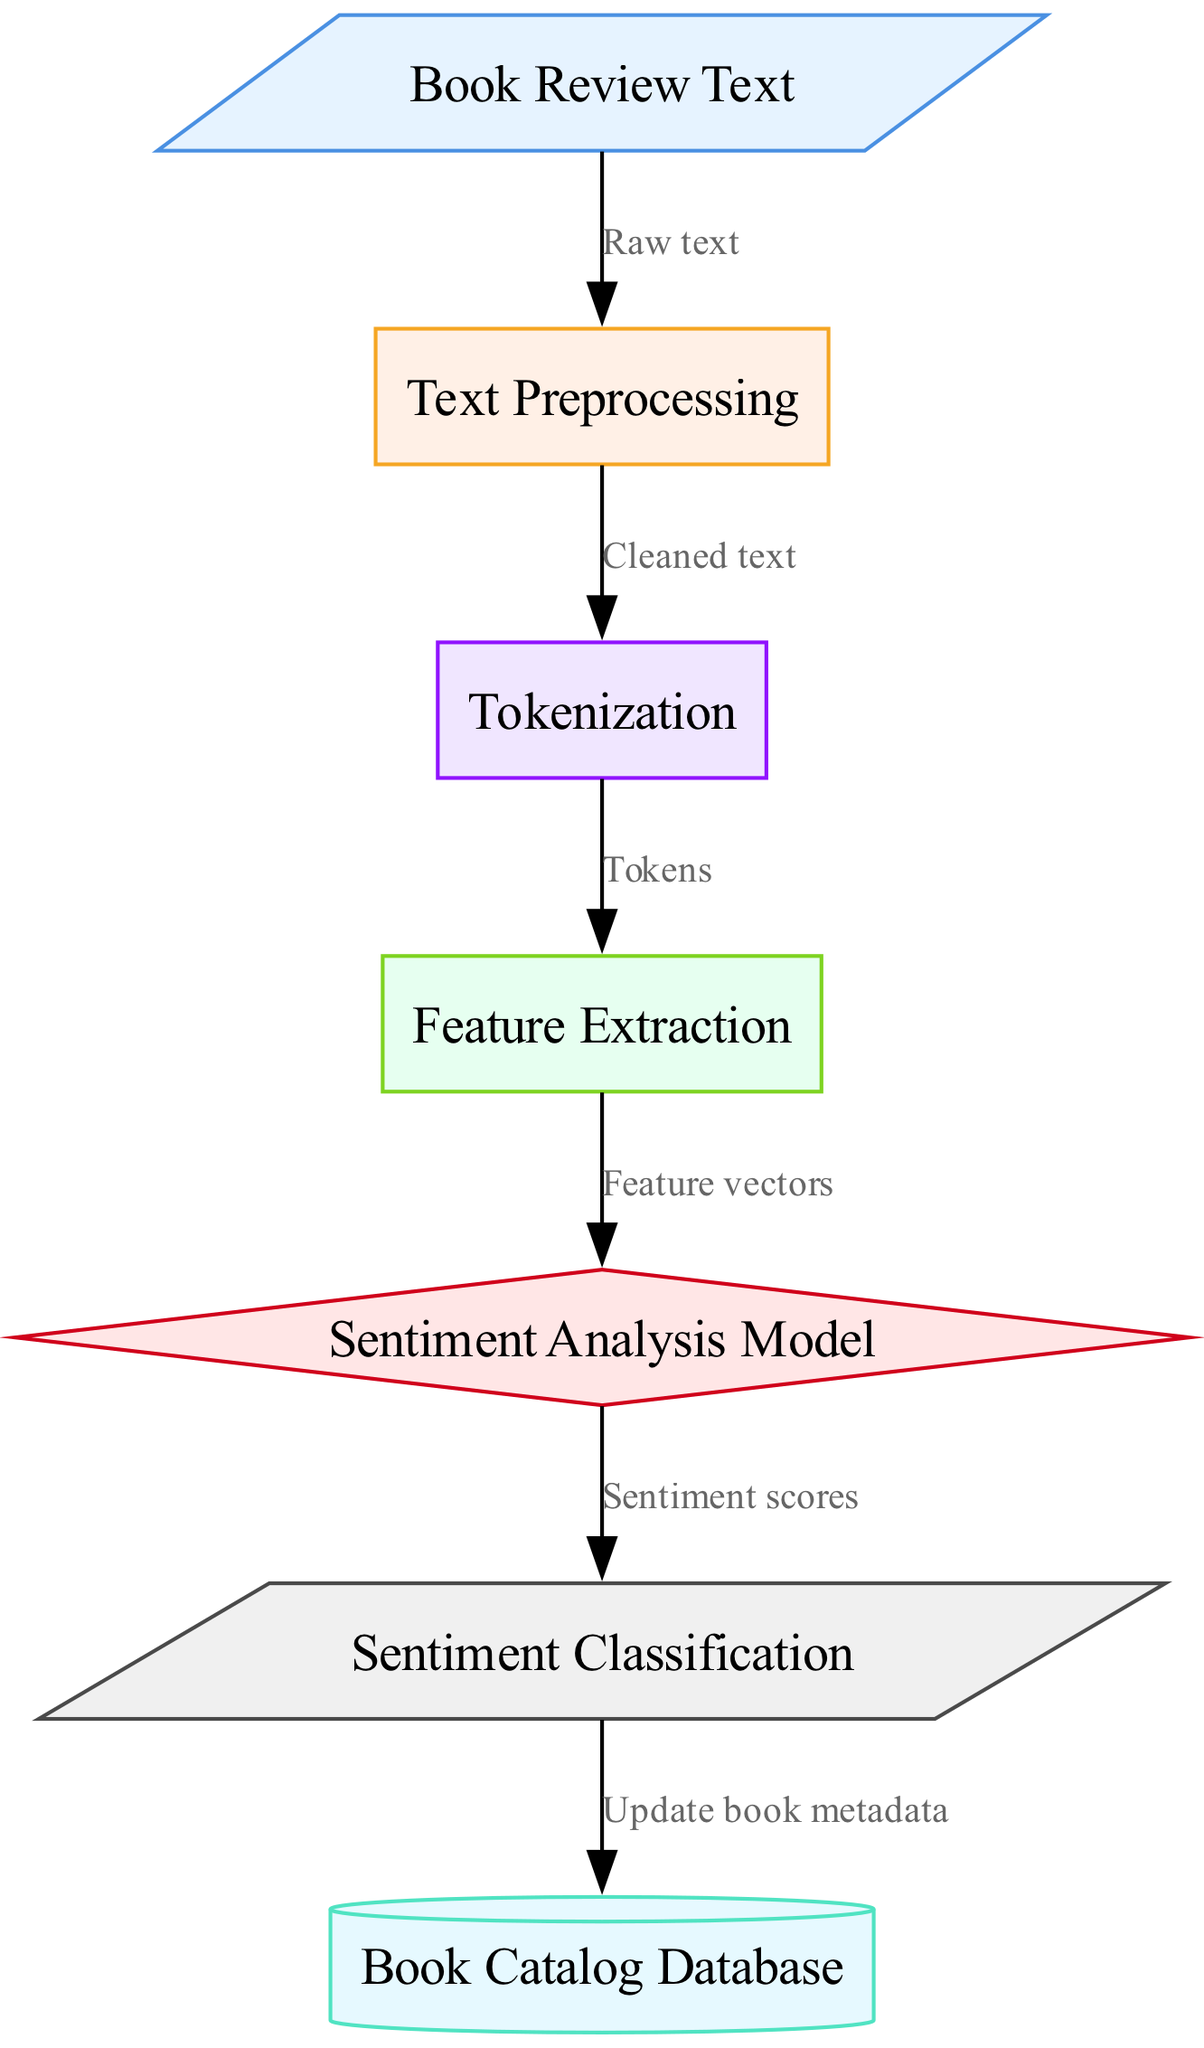What are the input and output of this diagram? The input of the diagram is "Book Review Text" and the output is "Sentiment Classification." Both are labeled at the beginning and end of the workflow.
Answer: Book Review Text, Sentiment Classification How many nodes are present in the diagram? The diagram contains 7 nodes, which are input, preprocessing, tokenization, feature extraction, model, output, and database.
Answer: 7 What type of node represents the sentiment analysis model? The sentiment analysis model is represented as a diamond-shaped node. This can be identified by its specific shape among the node types.
Answer: Diamond Which node is responsible for cleaning the text? The "Text Preprocessing" node is responsible for cleaning the text as indicated by the flow leading from "Book Review Text" to "Text Preprocessing."
Answer: Text Preprocessing What type of edge connects the "feature extraction" node to the "model" node? The edge connecting the "feature extraction" node to the "model" node represents "Feature vectors," indicating the output of feature extraction feeding into the model.
Answer: Feature vectors What is the purpose of the "Sentiment Analysis Model" node? The purpose of the "Sentiment Analysis Model" is to process the extracted features and provide "Sentiment scores," which are outputs leading to sentiment classification.
Answer: Sentiment scores How does the output from the "output" node affect the "database" node? The output from the "output" node, which corresponds to "Sentiment Classification," triggers an update in the "Book Catalog Database" as indicated by the directed edge.
Answer: Update book metadata What is the significance of the "Tokenization" step in the workflow? The "Tokenization" step breaks the cleaned text into "Tokens," which are essential for converting the text into a format the machine learning model can understand.
Answer: Tokens What kind of relationship does the "preprocessing" node have with the "tokenization" node? The relationship is sequential; the "preprocessing" node outputs "Cleaned text," which is the input for the "tokenization" node.
Answer: Sequential relationship 